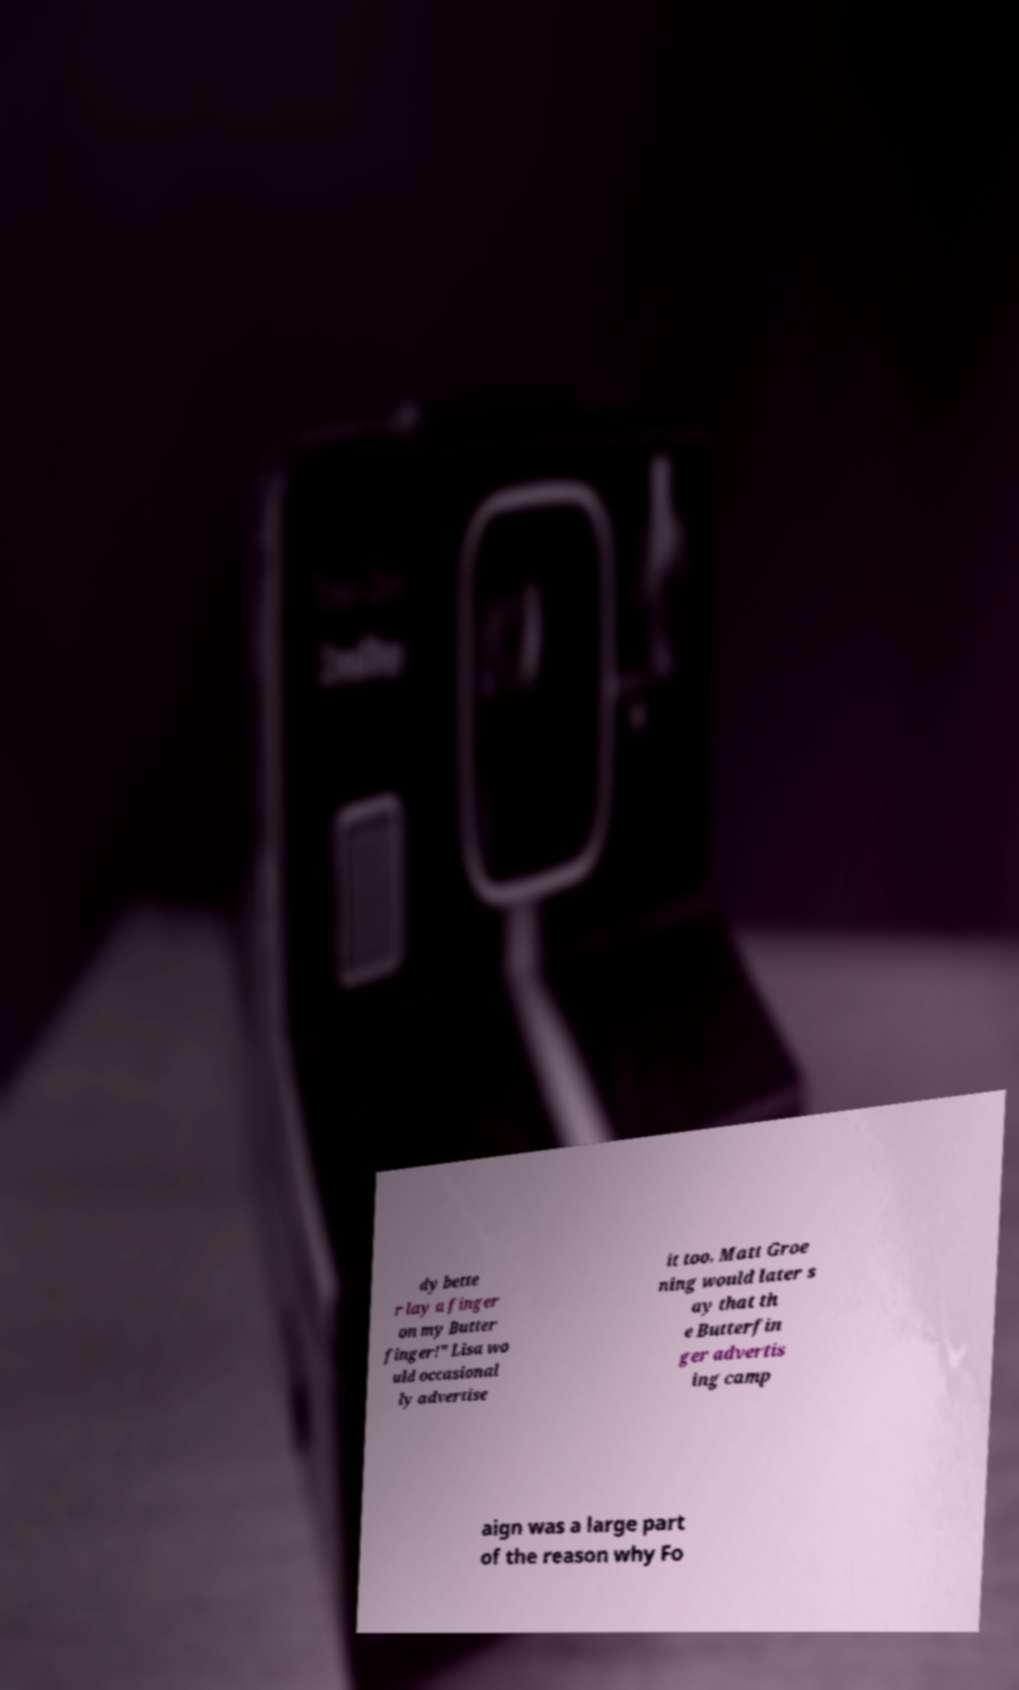Could you extract and type out the text from this image? dy bette r lay a finger on my Butter finger!" Lisa wo uld occasional ly advertise it too. Matt Groe ning would later s ay that th e Butterfin ger advertis ing camp aign was a large part of the reason why Fo 